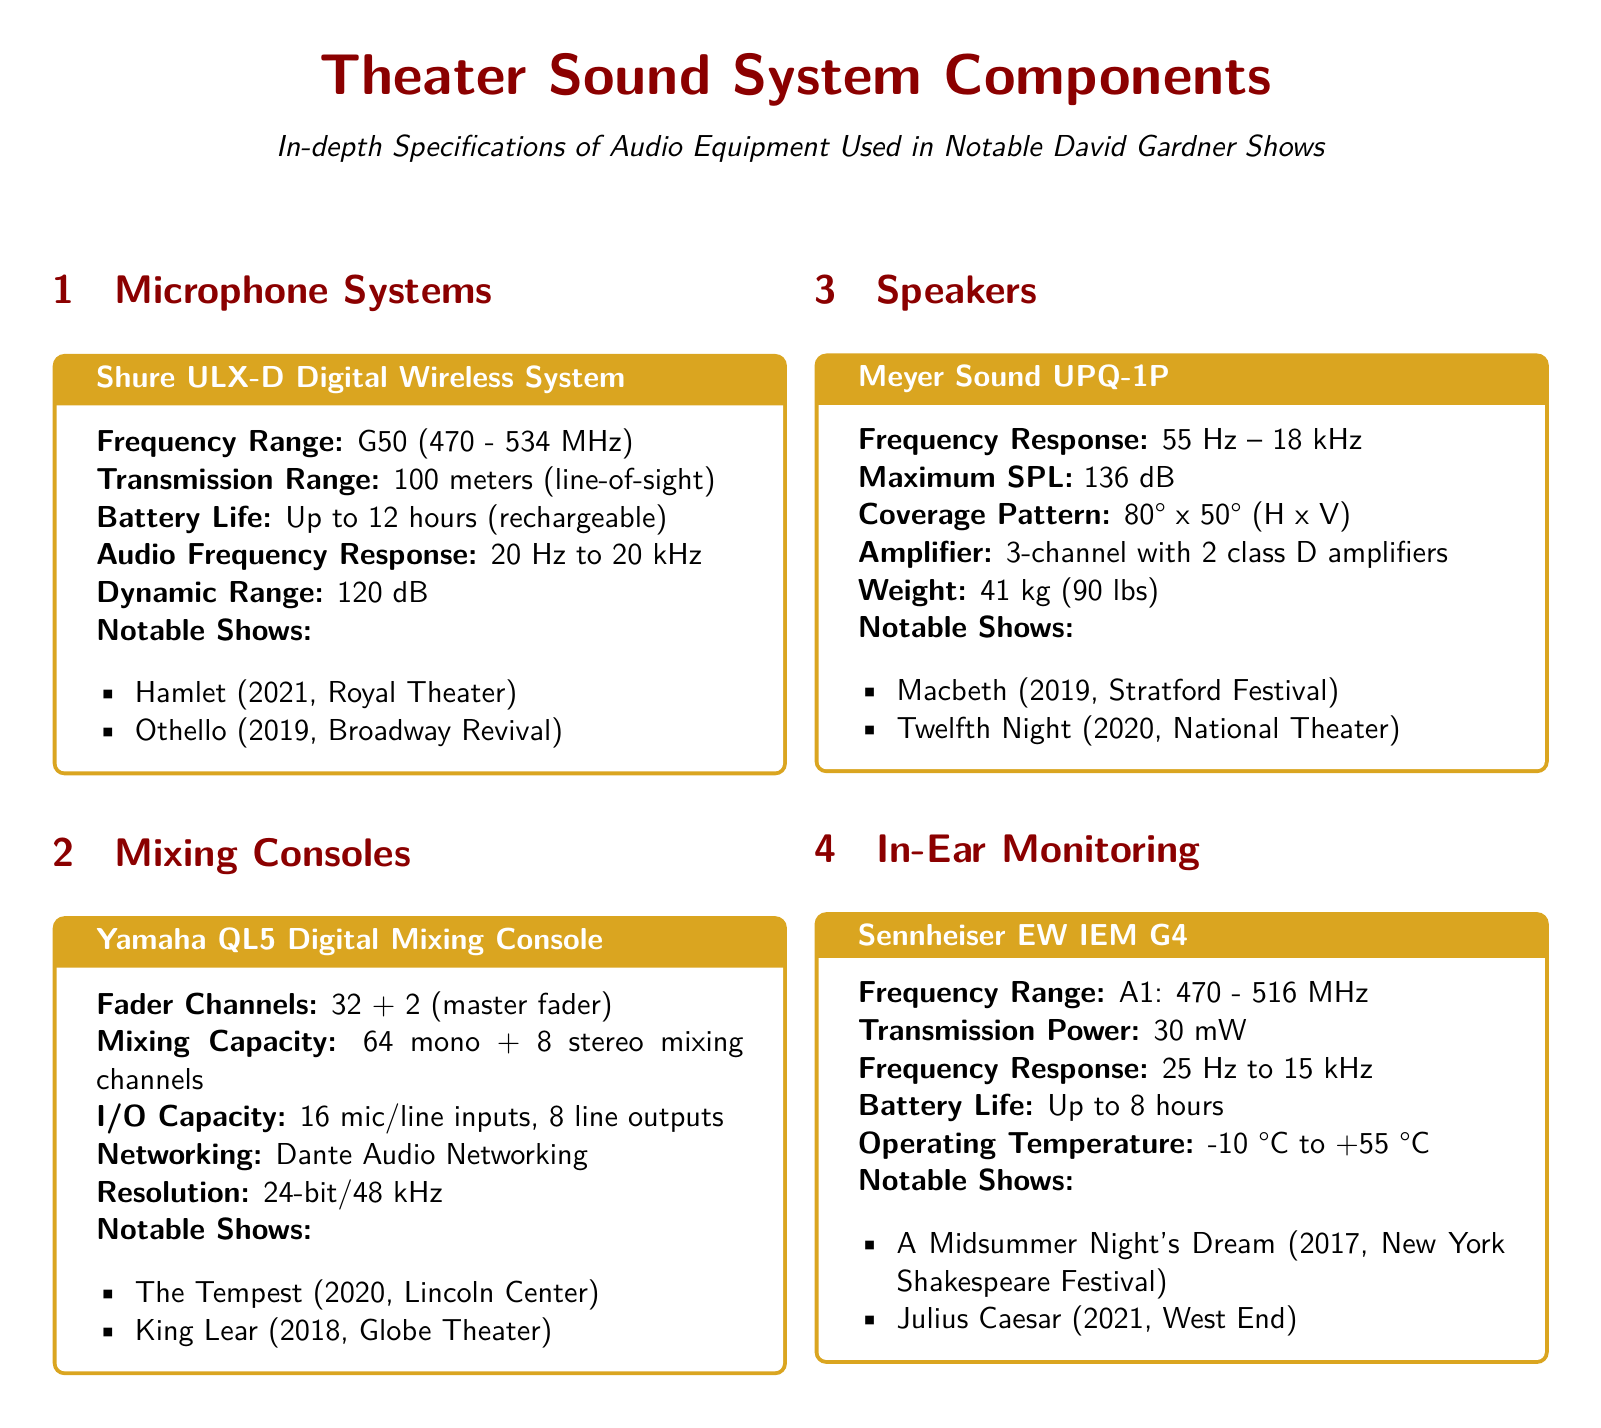What is the frequency range of the Shure ULX-D Digital Wireless System? The frequency range is specified in the document as G50 (470 - 534 MHz).
Answer: G50 (470 - 534 MHz) How many channels does the Yamaha QL5 Digital Mixing Console have? The document states that it has 32 + 2 (master fader) fader channels, which indicates the total number of channels available.
Answer: 32 + 2 What is the maximum SPL of the Meyer Sound UPQ-1P? The maximum SPL is mentioned as 136 dB in the specifications.
Answer: 136 dB Which notable show used the Sennheiser EW IEM G4? The document lists "A Midsummer Night's Dream (2017, New York Shakespeare Festival)" among the notable shows that utilized this equipment.
Answer: A Midsummer Night's Dream What is the audio frequency response of the Shure ULX-D Digital Wireless System? The document provides that the audio frequency response is between 20 Hz to 20 kHz.
Answer: 20 Hz to 20 kHz How many mixing channels can the Yamaha QL5 mixing console handle? According to the document, its mixing capacity includes 64 mono and 8 stereo mixing channels.
Answer: 64 mono + 8 stereo What type of amplifier does the Meyer Sound UPQ-1P use? The document indicates that it includes a 3-channel amplifier with 2 class D amplifiers.
Answer: 3-channel with 2 class D amplifiers What is the battery life of the Sennheiser EW IEM G4? The specifications in the document explain that the Sennheiser EW IEM G4 has a battery life of up to 8 hours.
Answer: Up to 8 hours What document type is this? Understanding the context of the content reveals that this is a product specification sheet aimed at detailing audio equipment.
Answer: Product specification sheet 